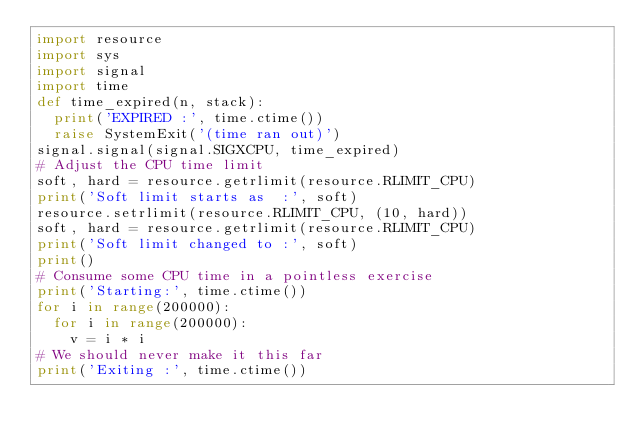Convert code to text. <code><loc_0><loc_0><loc_500><loc_500><_Python_>import resource
import sys
import signal
import time
def time_expired(n, stack):
	print('EXPIRED :', time.ctime())
	raise SystemExit('(time ran out)')
signal.signal(signal.SIGXCPU, time_expired)
# Adjust the CPU time limit
soft, hard = resource.getrlimit(resource.RLIMIT_CPU)
print('Soft limit starts as  :', soft)
resource.setrlimit(resource.RLIMIT_CPU, (10, hard))
soft, hard = resource.getrlimit(resource.RLIMIT_CPU)
print('Soft limit changed to :', soft)
print()
# Consume some CPU time in a pointless exercise
print('Starting:', time.ctime())
for i in range(200000):
	for i in range(200000):
		v = i * i
# We should never make it this far
print('Exiting :', time.ctime())

</code> 